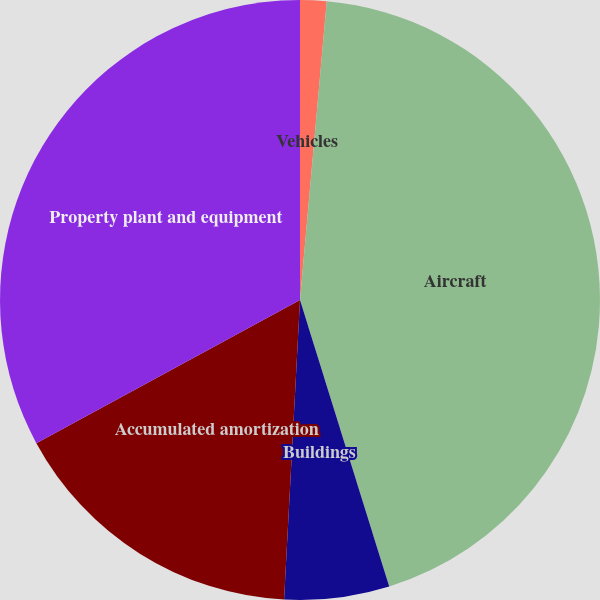Convert chart. <chart><loc_0><loc_0><loc_500><loc_500><pie_chart><fcel>Vehicles<fcel>Aircraft<fcel>Buildings<fcel>Accumulated amortization<fcel>Property plant and equipment<nl><fcel>1.42%<fcel>43.78%<fcel>5.65%<fcel>16.24%<fcel>32.92%<nl></chart> 